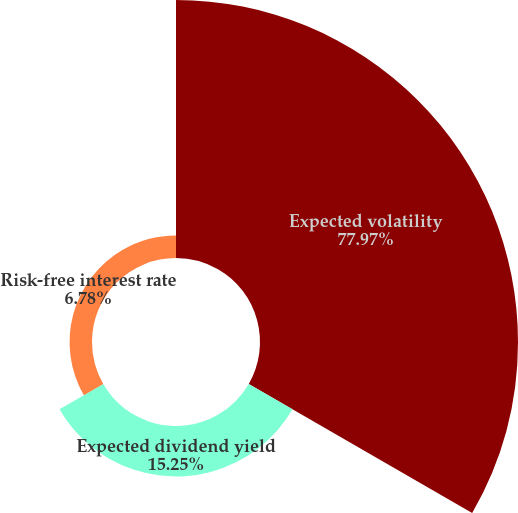Convert chart. <chart><loc_0><loc_0><loc_500><loc_500><pie_chart><fcel>Expected volatility<fcel>Expected dividend yield<fcel>Risk-free interest rate<nl><fcel>77.97%<fcel>15.25%<fcel>6.78%<nl></chart> 